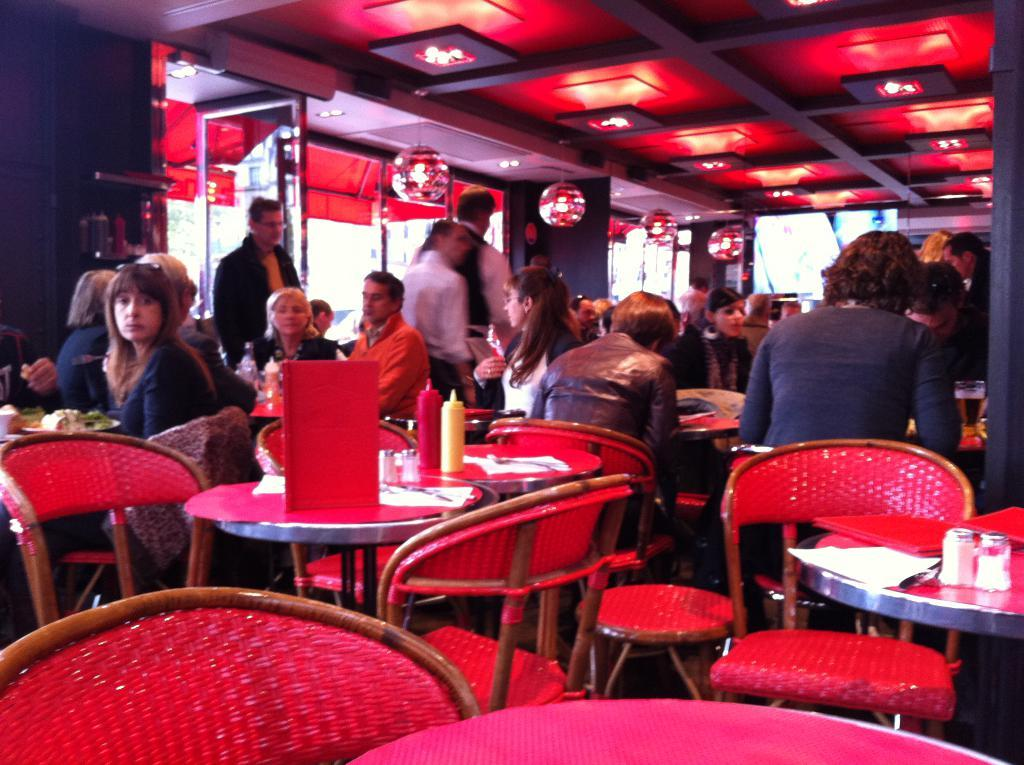What are the people in the image doing? There are people sitting on chairs and standing in the image. What type of furniture is present in the image? There are chairs and tables in the image. What can be seen hanging from the ceiling in the image? There are lights in the image. What is the background of the image made of? There is a wall in the image. What is on top of the tables in the image? There are objects on the tables in the image. Can you see any yaks in the image? No, there are no yaks present in the image. What type of fang is visible on the person standing in the image? There are no fangs visible on any person in the image. 